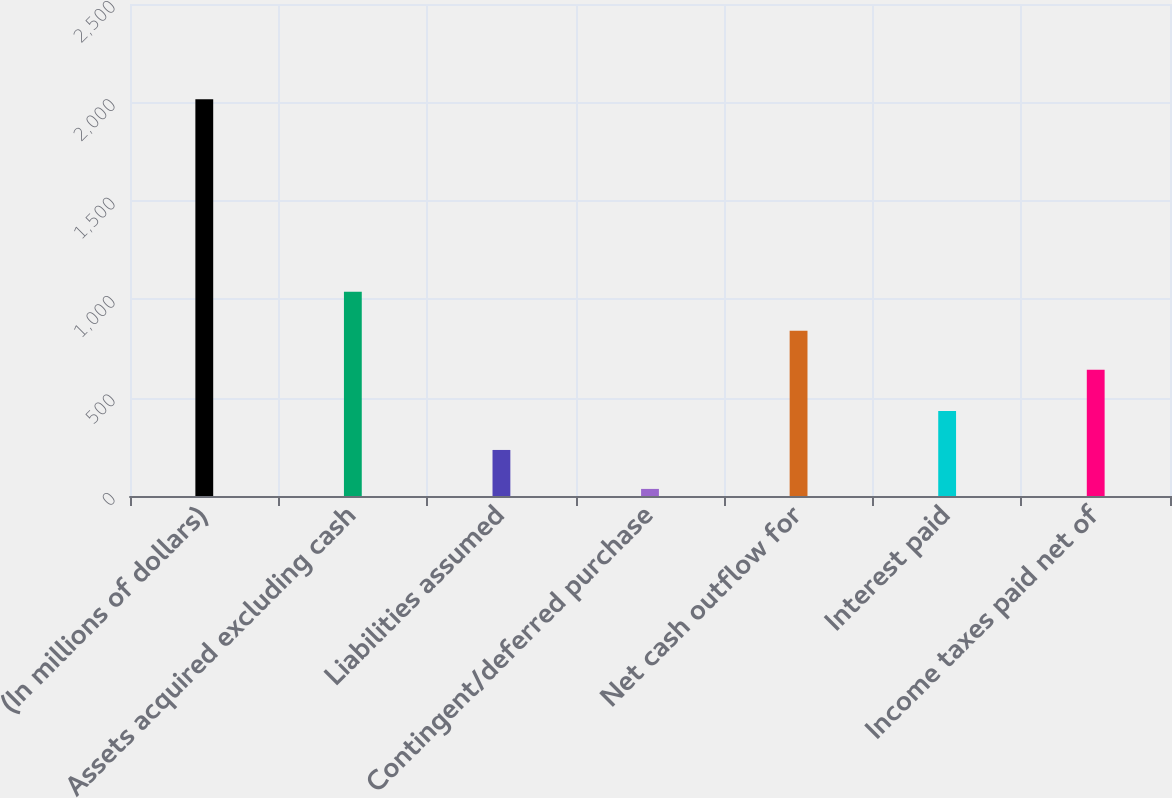Convert chart to OTSL. <chart><loc_0><loc_0><loc_500><loc_500><bar_chart><fcel>(In millions of dollars)<fcel>Assets acquired excluding cash<fcel>Liabilities assumed<fcel>Contingent/deferred purchase<fcel>Net cash outflow for<fcel>Interest paid<fcel>Income taxes paid net of<nl><fcel>2016<fcel>1038<fcel>234<fcel>36<fcel>840<fcel>432<fcel>642<nl></chart> 